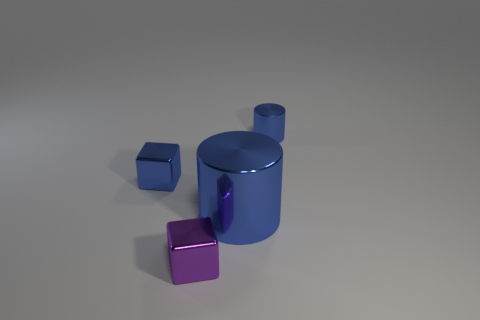What shape is the tiny thing that is the same color as the small cylinder?
Offer a terse response. Cube. What number of other objects are the same shape as the big blue thing?
Provide a short and direct response. 1. There is a small blue thing that is the same shape as the large blue object; what is it made of?
Make the answer very short. Metal. Is the material of the small object to the left of the tiny purple block the same as the small purple cube?
Keep it short and to the point. Yes. Are there an equal number of metallic cylinders in front of the small blue metal block and large blue objects that are on the left side of the tiny metallic cylinder?
Ensure brevity in your answer.  Yes. There is a blue object to the left of the tiny shiny thing in front of the big cylinder; what is its size?
Give a very brief answer. Small. What is the object that is behind the purple metallic object and to the left of the big blue metallic cylinder made of?
Ensure brevity in your answer.  Metal. How many other objects are there of the same size as the purple metal thing?
Offer a terse response. 2. The big cylinder has what color?
Provide a succinct answer. Blue. There is a metallic cylinder in front of the tiny blue cylinder; does it have the same color as the tiny shiny cube behind the large blue shiny cylinder?
Your answer should be very brief. Yes. 